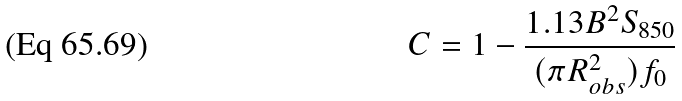Convert formula to latex. <formula><loc_0><loc_0><loc_500><loc_500>C = 1 - \frac { 1 . 1 3 B ^ { 2 } S _ { 8 5 0 } } { ( \pi R ^ { 2 } _ { o b s } ) f _ { 0 } }</formula> 